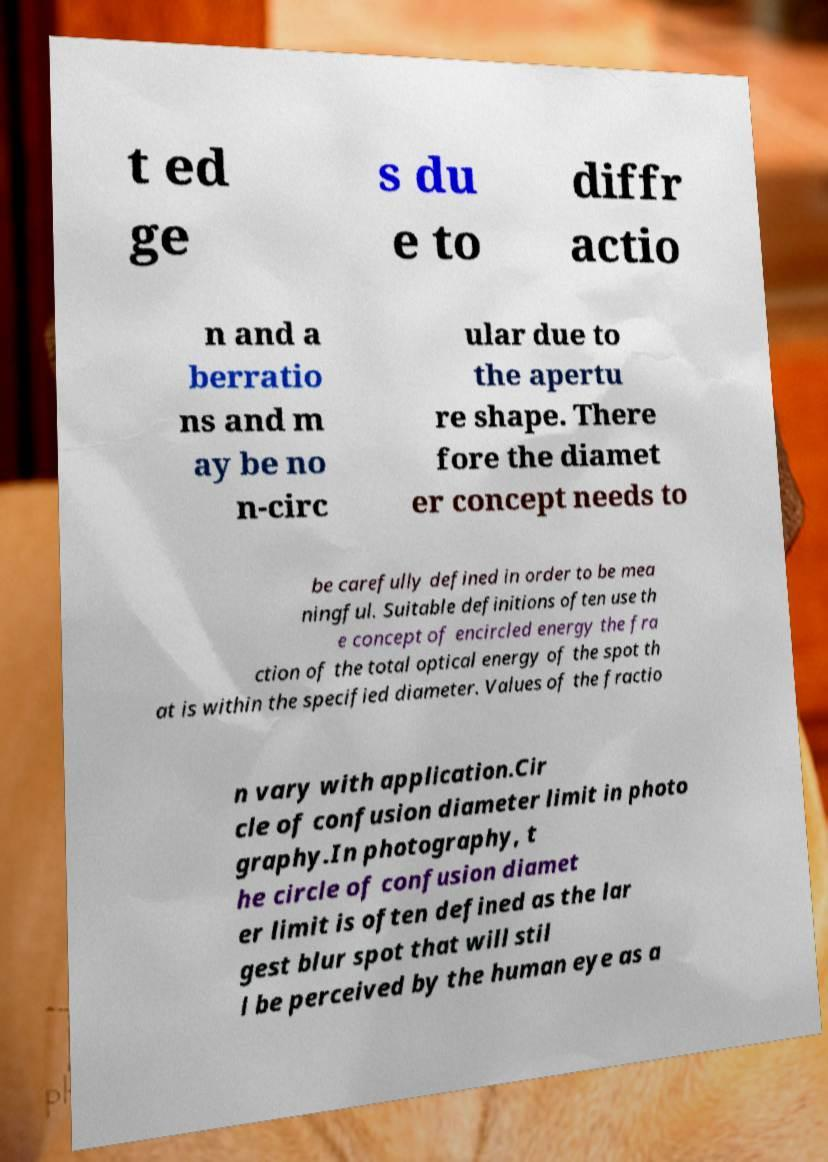There's text embedded in this image that I need extracted. Can you transcribe it verbatim? t ed ge s du e to diffr actio n and a berratio ns and m ay be no n-circ ular due to the apertu re shape. There fore the diamet er concept needs to be carefully defined in order to be mea ningful. Suitable definitions often use th e concept of encircled energy the fra ction of the total optical energy of the spot th at is within the specified diameter. Values of the fractio n vary with application.Cir cle of confusion diameter limit in photo graphy.In photography, t he circle of confusion diamet er limit is often defined as the lar gest blur spot that will stil l be perceived by the human eye as a 